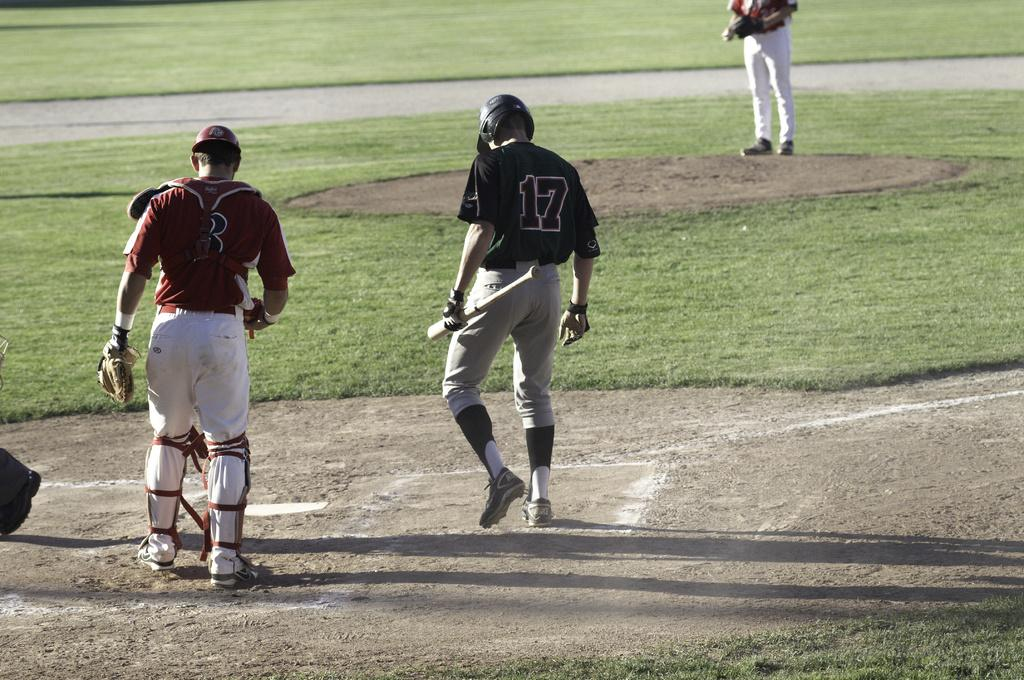How many players are visible in the image? There are two players standing on the ground in the image. What can be seen in the background of the image? There is grassy land in the background of the image. Are there any other people present in the image besides the players? Yes, there is at least one other man present in the image. What type of bun is being used as a prop in the image? There is no bun present in the image; it features two players and a grassy background. Can you tell me how many cannons are visible in the image? There are no cannons present in the image. 